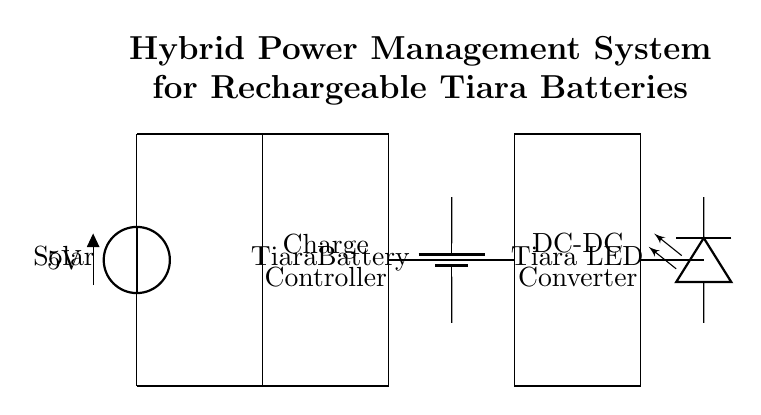What components are present in this circuit? The circuit includes a solar panel, charge controller, Tiara battery, DC-DC converter, and Tiara LED.
Answer: solar panel, charge controller, Tiara battery, DC-DC converter, Tiara LED What is the voltage output of the solar panel? The solar panel indicates a voltage of five volts, which is shown next to it.
Answer: 5 volts What is the function of the charge controller? The charge controller's primary role is to manage the charging of the Tiara battery, ensuring that it does not overcharge.
Answer: manage battery charging How is the Tiara battery connected in the circuit? The Tiara battery is connected directly from the charge controller to the DC-DC converter, allowing it to receive charge and supply power to the LED.
Answer: between charge controller and DC-DC converter Which component converts DC voltage levels? The DC-DC converter is the component that adjusts the DC voltage levels to suit the requirements of the load, which is the Tiara LED.
Answer: DC-DC converter How does the power management system maintain functionality during varying light conditions? The hybrid system integrates a solar panel and potentially other power sources, which allows it to adaptively charge the battery and maintain LED operation even when light conditions fluctuate.
Answer: hybrid power source What is the load in this circuit? The load is connected at the end of the circuit and is identified as the Tiara LED, which consumes power from the battery.
Answer: Tiara LED 